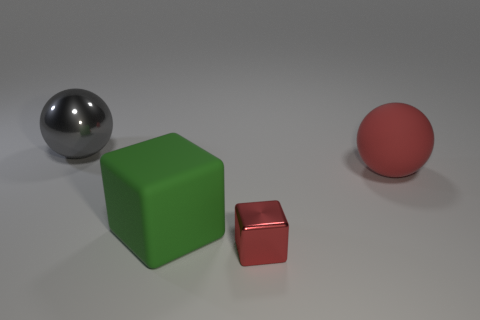How many other objects are there of the same size as the red block?
Provide a short and direct response. 0. Are the large ball that is on the right side of the large green matte object and the gray ball left of the green cube made of the same material?
Your answer should be very brief. No. What is the size of the sphere that is behind the red thing behind the matte cube?
Ensure brevity in your answer.  Large. Is there another shiny ball that has the same color as the metal ball?
Offer a terse response. No. Is the color of the thing that is left of the green object the same as the sphere on the right side of the small metallic object?
Give a very brief answer. No. What is the shape of the big green matte object?
Your answer should be compact. Cube. There is a large gray metallic object; what number of large red balls are behind it?
Keep it short and to the point. 0. How many red objects are the same material as the big green block?
Offer a very short reply. 1. Does the ball that is in front of the big gray object have the same material as the big gray thing?
Offer a terse response. No. Are there any tiny blue rubber blocks?
Give a very brief answer. No. 